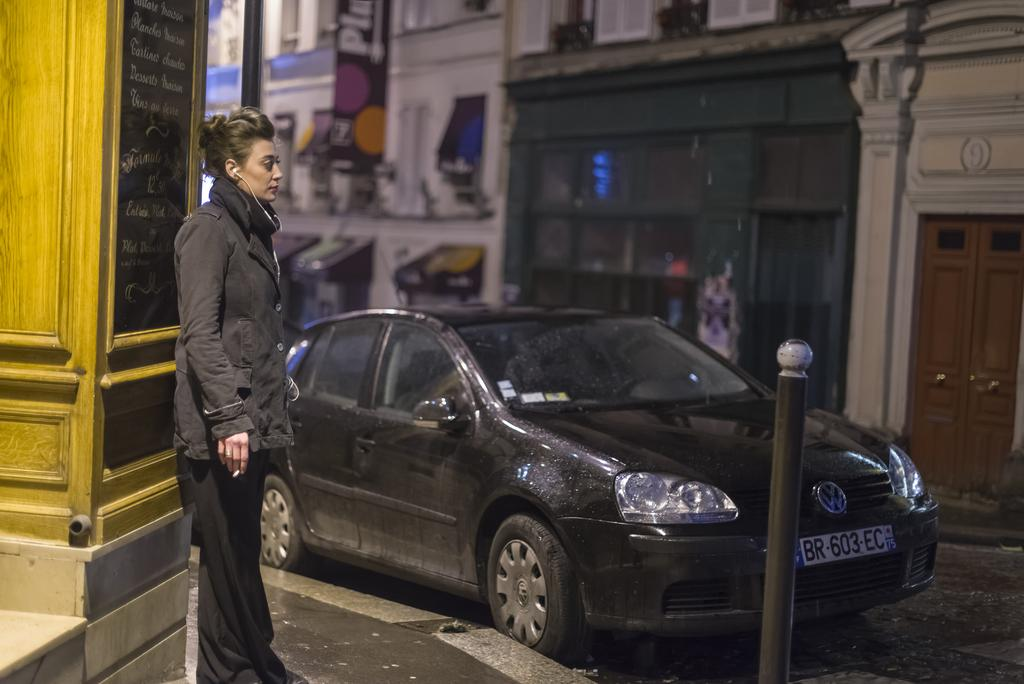Who is present in the image? There is a woman in the image. What is the woman wearing? The woman is wearing a black jacket. Where is the woman located in the image? The woman is standing on the side of the road. What is in front of the woman? There is a wall in front of the woman. What can be seen in the middle of the road? There is a car in the middle of the road. What is visible behind the car? There are buildings behind the car. What type of tray is the woman holding in the image? There is no tray present in the image; the woman is not holding anything. 